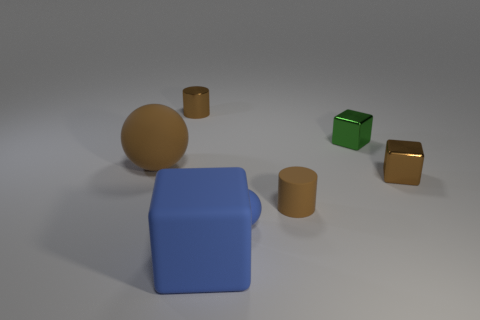The tiny green thing has what shape?
Offer a very short reply. Cube. Are there more tiny blue matte objects that are on the right side of the small green shiny object than tiny brown things left of the large blue block?
Offer a terse response. No. How many other objects are the same size as the green metal block?
Your answer should be compact. 4. There is a object that is in front of the brown metal block and on the left side of the small matte sphere; what is its material?
Offer a very short reply. Rubber. There is a green object that is the same shape as the big blue thing; what material is it?
Provide a succinct answer. Metal. There is a blue block right of the matte object that is to the left of the rubber block; how many cylinders are to the right of it?
Your answer should be compact. 1. Are there any other things that have the same color as the tiny matte cylinder?
Provide a short and direct response. Yes. What number of things are to the left of the small green thing and in front of the big brown ball?
Offer a terse response. 3. There is a brown metallic block that is in front of the small metallic cylinder; is it the same size as the cylinder in front of the metallic cylinder?
Keep it short and to the point. Yes. What number of objects are either large blue rubber objects that are on the left side of the brown rubber cylinder or small gray metallic cylinders?
Provide a succinct answer. 1. 